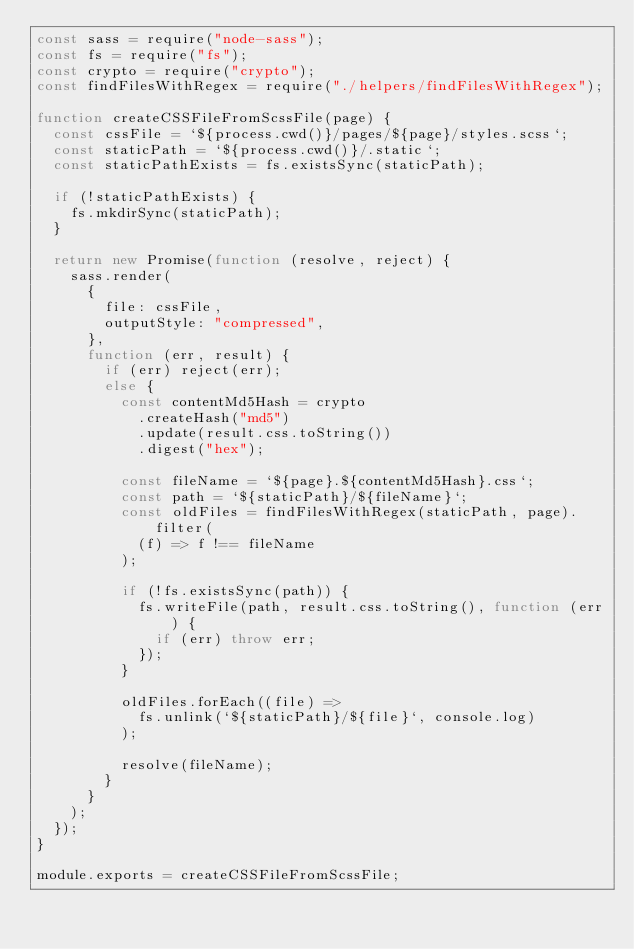Convert code to text. <code><loc_0><loc_0><loc_500><loc_500><_JavaScript_>const sass = require("node-sass");
const fs = require("fs");
const crypto = require("crypto");
const findFilesWithRegex = require("./helpers/findFilesWithRegex");

function createCSSFileFromScssFile(page) {
  const cssFile = `${process.cwd()}/pages/${page}/styles.scss`;
  const staticPath = `${process.cwd()}/.static`;
  const staticPathExists = fs.existsSync(staticPath);

  if (!staticPathExists) {
    fs.mkdirSync(staticPath);
  }

  return new Promise(function (resolve, reject) {
    sass.render(
      {
        file: cssFile,
        outputStyle: "compressed",
      },
      function (err, result) {
        if (err) reject(err);
        else {
          const contentMd5Hash = crypto
            .createHash("md5")
            .update(result.css.toString())
            .digest("hex");

          const fileName = `${page}.${contentMd5Hash}.css`;
          const path = `${staticPath}/${fileName}`;
          const oldFiles = findFilesWithRegex(staticPath, page).filter(
            (f) => f !== fileName
          );

          if (!fs.existsSync(path)) {
            fs.writeFile(path, result.css.toString(), function (err) {
              if (err) throw err;
            });
          }

          oldFiles.forEach((file) =>
            fs.unlink(`${staticPath}/${file}`, console.log)
          );

          resolve(fileName);
        }
      }
    );
  });
}

module.exports = createCSSFileFromScssFile;
</code> 